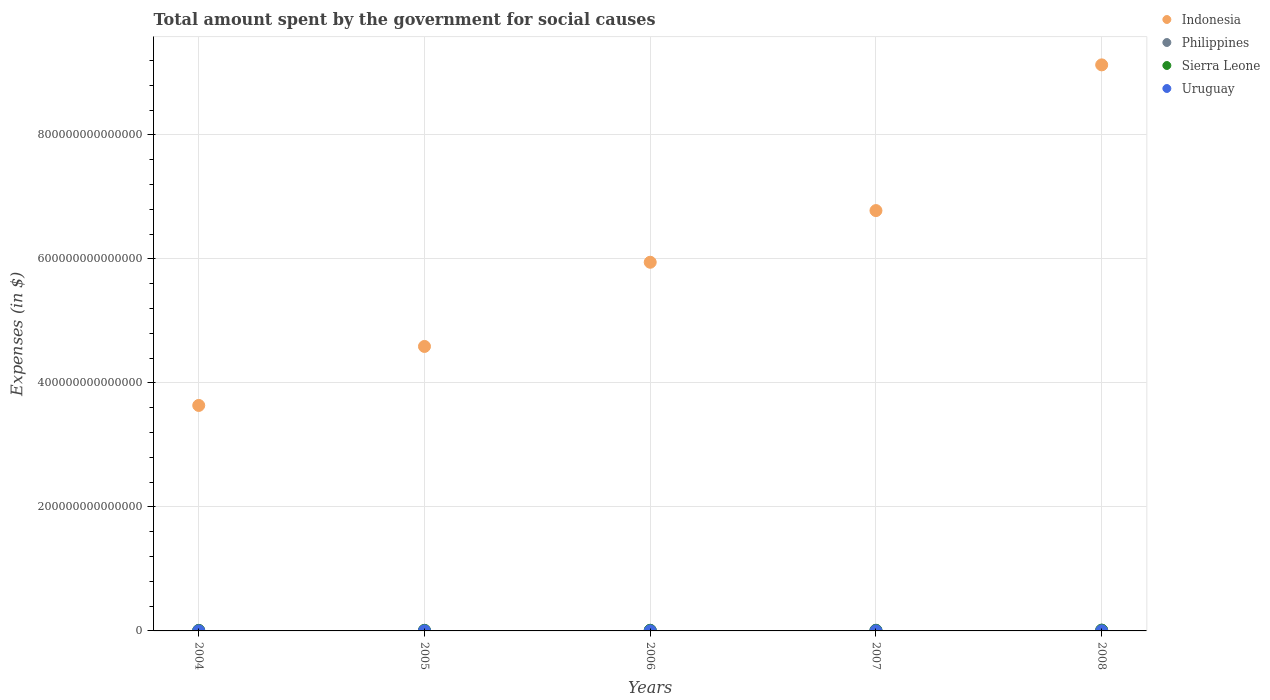How many different coloured dotlines are there?
Your answer should be compact. 4. Is the number of dotlines equal to the number of legend labels?
Offer a terse response. Yes. What is the amount spent for social causes by the government in Uruguay in 2008?
Keep it short and to the point. 1.63e+11. Across all years, what is the maximum amount spent for social causes by the government in Sierra Leone?
Your answer should be very brief. 1.18e+12. Across all years, what is the minimum amount spent for social causes by the government in Philippines?
Ensure brevity in your answer.  9.06e+11. In which year was the amount spent for social causes by the government in Philippines maximum?
Offer a terse response. 2008. In which year was the amount spent for social causes by the government in Indonesia minimum?
Offer a terse response. 2004. What is the total amount spent for social causes by the government in Philippines in the graph?
Provide a short and direct response. 5.35e+12. What is the difference between the amount spent for social causes by the government in Uruguay in 2007 and that in 2008?
Offer a very short reply. -1.73e+1. What is the difference between the amount spent for social causes by the government in Uruguay in 2004 and the amount spent for social causes by the government in Sierra Leone in 2005?
Give a very brief answer. -7.18e+11. What is the average amount spent for social causes by the government in Uruguay per year?
Offer a very short reply. 1.30e+11. In the year 2006, what is the difference between the amount spent for social causes by the government in Indonesia and amount spent for social causes by the government in Uruguay?
Make the answer very short. 5.94e+14. In how many years, is the amount spent for social causes by the government in Uruguay greater than 240000000000000 $?
Offer a terse response. 0. What is the ratio of the amount spent for social causes by the government in Philippines in 2006 to that in 2007?
Make the answer very short. 0.92. Is the amount spent for social causes by the government in Philippines in 2004 less than that in 2007?
Your response must be concise. Yes. What is the difference between the highest and the second highest amount spent for social causes by the government in Philippines?
Offer a very short reply. 1.21e+11. What is the difference between the highest and the lowest amount spent for social causes by the government in Indonesia?
Offer a terse response. 5.49e+14. In how many years, is the amount spent for social causes by the government in Sierra Leone greater than the average amount spent for social causes by the government in Sierra Leone taken over all years?
Your answer should be very brief. 2. Is the sum of the amount spent for social causes by the government in Uruguay in 2007 and 2008 greater than the maximum amount spent for social causes by the government in Indonesia across all years?
Your response must be concise. No. Does the amount spent for social causes by the government in Philippines monotonically increase over the years?
Provide a short and direct response. Yes. Is the amount spent for social causes by the government in Indonesia strictly less than the amount spent for social causes by the government in Uruguay over the years?
Provide a short and direct response. No. How many dotlines are there?
Keep it short and to the point. 4. How many years are there in the graph?
Your response must be concise. 5. What is the difference between two consecutive major ticks on the Y-axis?
Your answer should be compact. 2.00e+14. Does the graph contain any zero values?
Give a very brief answer. No. How are the legend labels stacked?
Provide a short and direct response. Vertical. What is the title of the graph?
Ensure brevity in your answer.  Total amount spent by the government for social causes. What is the label or title of the X-axis?
Ensure brevity in your answer.  Years. What is the label or title of the Y-axis?
Provide a succinct answer. Expenses (in $). What is the Expenses (in $) in Indonesia in 2004?
Make the answer very short. 3.64e+14. What is the Expenses (in $) of Philippines in 2004?
Your answer should be compact. 9.06e+11. What is the Expenses (in $) of Sierra Leone in 2004?
Make the answer very short. 6.88e+11. What is the Expenses (in $) of Uruguay in 2004?
Offer a terse response. 1.04e+11. What is the Expenses (in $) in Indonesia in 2005?
Your response must be concise. 4.59e+14. What is the Expenses (in $) in Philippines in 2005?
Keep it short and to the point. 9.77e+11. What is the Expenses (in $) of Sierra Leone in 2005?
Give a very brief answer. 8.23e+11. What is the Expenses (in $) of Uruguay in 2005?
Your response must be concise. 1.13e+11. What is the Expenses (in $) in Indonesia in 2006?
Offer a terse response. 5.94e+14. What is the Expenses (in $) in Philippines in 2006?
Keep it short and to the point. 1.05e+12. What is the Expenses (in $) in Sierra Leone in 2006?
Your answer should be compact. 9.17e+11. What is the Expenses (in $) of Uruguay in 2006?
Your response must be concise. 1.27e+11. What is the Expenses (in $) of Indonesia in 2007?
Offer a terse response. 6.78e+14. What is the Expenses (in $) of Philippines in 2007?
Offer a very short reply. 1.15e+12. What is the Expenses (in $) in Sierra Leone in 2007?
Keep it short and to the point. 8.25e+11. What is the Expenses (in $) in Uruguay in 2007?
Your answer should be compact. 1.46e+11. What is the Expenses (in $) in Indonesia in 2008?
Keep it short and to the point. 9.13e+14. What is the Expenses (in $) in Philippines in 2008?
Provide a succinct answer. 1.27e+12. What is the Expenses (in $) in Sierra Leone in 2008?
Ensure brevity in your answer.  1.18e+12. What is the Expenses (in $) of Uruguay in 2008?
Give a very brief answer. 1.63e+11. Across all years, what is the maximum Expenses (in $) of Indonesia?
Keep it short and to the point. 9.13e+14. Across all years, what is the maximum Expenses (in $) of Philippines?
Offer a very short reply. 1.27e+12. Across all years, what is the maximum Expenses (in $) in Sierra Leone?
Your response must be concise. 1.18e+12. Across all years, what is the maximum Expenses (in $) of Uruguay?
Provide a succinct answer. 1.63e+11. Across all years, what is the minimum Expenses (in $) in Indonesia?
Provide a short and direct response. 3.64e+14. Across all years, what is the minimum Expenses (in $) in Philippines?
Give a very brief answer. 9.06e+11. Across all years, what is the minimum Expenses (in $) of Sierra Leone?
Your response must be concise. 6.88e+11. Across all years, what is the minimum Expenses (in $) of Uruguay?
Offer a terse response. 1.04e+11. What is the total Expenses (in $) in Indonesia in the graph?
Your answer should be compact. 3.01e+15. What is the total Expenses (in $) of Philippines in the graph?
Ensure brevity in your answer.  5.35e+12. What is the total Expenses (in $) of Sierra Leone in the graph?
Keep it short and to the point. 4.44e+12. What is the total Expenses (in $) of Uruguay in the graph?
Your answer should be compact. 6.52e+11. What is the difference between the Expenses (in $) in Indonesia in 2004 and that in 2005?
Offer a very short reply. -9.51e+13. What is the difference between the Expenses (in $) in Philippines in 2004 and that in 2005?
Give a very brief answer. -7.12e+1. What is the difference between the Expenses (in $) in Sierra Leone in 2004 and that in 2005?
Ensure brevity in your answer.  -1.35e+11. What is the difference between the Expenses (in $) of Uruguay in 2004 and that in 2005?
Your answer should be compact. -8.41e+09. What is the difference between the Expenses (in $) in Indonesia in 2004 and that in 2006?
Your answer should be very brief. -2.31e+14. What is the difference between the Expenses (in $) in Philippines in 2004 and that in 2006?
Give a very brief answer. -1.48e+11. What is the difference between the Expenses (in $) in Sierra Leone in 2004 and that in 2006?
Your answer should be compact. -2.29e+11. What is the difference between the Expenses (in $) of Uruguay in 2004 and that in 2006?
Your answer should be very brief. -2.22e+1. What is the difference between the Expenses (in $) of Indonesia in 2004 and that in 2007?
Offer a terse response. -3.14e+14. What is the difference between the Expenses (in $) in Philippines in 2004 and that in 2007?
Make the answer very short. -2.39e+11. What is the difference between the Expenses (in $) in Sierra Leone in 2004 and that in 2007?
Your answer should be compact. -1.37e+11. What is the difference between the Expenses (in $) of Uruguay in 2004 and that in 2007?
Offer a terse response. -4.11e+1. What is the difference between the Expenses (in $) in Indonesia in 2004 and that in 2008?
Offer a very short reply. -5.49e+14. What is the difference between the Expenses (in $) of Philippines in 2004 and that in 2008?
Provide a short and direct response. -3.60e+11. What is the difference between the Expenses (in $) of Sierra Leone in 2004 and that in 2008?
Your answer should be very brief. -4.97e+11. What is the difference between the Expenses (in $) in Uruguay in 2004 and that in 2008?
Your answer should be very brief. -5.84e+1. What is the difference between the Expenses (in $) in Indonesia in 2005 and that in 2006?
Your answer should be very brief. -1.36e+14. What is the difference between the Expenses (in $) of Philippines in 2005 and that in 2006?
Provide a short and direct response. -7.71e+1. What is the difference between the Expenses (in $) in Sierra Leone in 2005 and that in 2006?
Provide a short and direct response. -9.44e+1. What is the difference between the Expenses (in $) of Uruguay in 2005 and that in 2006?
Your response must be concise. -1.37e+1. What is the difference between the Expenses (in $) of Indonesia in 2005 and that in 2007?
Give a very brief answer. -2.19e+14. What is the difference between the Expenses (in $) in Philippines in 2005 and that in 2007?
Make the answer very short. -1.68e+11. What is the difference between the Expenses (in $) of Sierra Leone in 2005 and that in 2007?
Offer a very short reply. -1.90e+09. What is the difference between the Expenses (in $) in Uruguay in 2005 and that in 2007?
Ensure brevity in your answer.  -3.27e+1. What is the difference between the Expenses (in $) of Indonesia in 2005 and that in 2008?
Your answer should be very brief. -4.54e+14. What is the difference between the Expenses (in $) of Philippines in 2005 and that in 2008?
Your answer should be very brief. -2.89e+11. What is the difference between the Expenses (in $) in Sierra Leone in 2005 and that in 2008?
Keep it short and to the point. -3.62e+11. What is the difference between the Expenses (in $) in Uruguay in 2005 and that in 2008?
Offer a very short reply. -5.00e+1. What is the difference between the Expenses (in $) in Indonesia in 2006 and that in 2007?
Give a very brief answer. -8.33e+13. What is the difference between the Expenses (in $) in Philippines in 2006 and that in 2007?
Keep it short and to the point. -9.11e+1. What is the difference between the Expenses (in $) of Sierra Leone in 2006 and that in 2007?
Your answer should be very brief. 9.25e+1. What is the difference between the Expenses (in $) in Uruguay in 2006 and that in 2007?
Your response must be concise. -1.89e+1. What is the difference between the Expenses (in $) in Indonesia in 2006 and that in 2008?
Offer a very short reply. -3.18e+14. What is the difference between the Expenses (in $) in Philippines in 2006 and that in 2008?
Offer a very short reply. -2.12e+11. What is the difference between the Expenses (in $) in Sierra Leone in 2006 and that in 2008?
Ensure brevity in your answer.  -2.67e+11. What is the difference between the Expenses (in $) of Uruguay in 2006 and that in 2008?
Provide a succinct answer. -3.63e+1. What is the difference between the Expenses (in $) of Indonesia in 2007 and that in 2008?
Your response must be concise. -2.35e+14. What is the difference between the Expenses (in $) in Philippines in 2007 and that in 2008?
Offer a very short reply. -1.21e+11. What is the difference between the Expenses (in $) of Sierra Leone in 2007 and that in 2008?
Ensure brevity in your answer.  -3.60e+11. What is the difference between the Expenses (in $) in Uruguay in 2007 and that in 2008?
Make the answer very short. -1.73e+1. What is the difference between the Expenses (in $) in Indonesia in 2004 and the Expenses (in $) in Philippines in 2005?
Provide a succinct answer. 3.63e+14. What is the difference between the Expenses (in $) of Indonesia in 2004 and the Expenses (in $) of Sierra Leone in 2005?
Provide a succinct answer. 3.63e+14. What is the difference between the Expenses (in $) of Indonesia in 2004 and the Expenses (in $) of Uruguay in 2005?
Make the answer very short. 3.63e+14. What is the difference between the Expenses (in $) in Philippines in 2004 and the Expenses (in $) in Sierra Leone in 2005?
Ensure brevity in your answer.  8.26e+1. What is the difference between the Expenses (in $) of Philippines in 2004 and the Expenses (in $) of Uruguay in 2005?
Make the answer very short. 7.93e+11. What is the difference between the Expenses (in $) in Sierra Leone in 2004 and the Expenses (in $) in Uruguay in 2005?
Keep it short and to the point. 5.75e+11. What is the difference between the Expenses (in $) of Indonesia in 2004 and the Expenses (in $) of Philippines in 2006?
Provide a short and direct response. 3.63e+14. What is the difference between the Expenses (in $) of Indonesia in 2004 and the Expenses (in $) of Sierra Leone in 2006?
Your answer should be compact. 3.63e+14. What is the difference between the Expenses (in $) in Indonesia in 2004 and the Expenses (in $) in Uruguay in 2006?
Your answer should be compact. 3.63e+14. What is the difference between the Expenses (in $) of Philippines in 2004 and the Expenses (in $) of Sierra Leone in 2006?
Provide a succinct answer. -1.17e+1. What is the difference between the Expenses (in $) in Philippines in 2004 and the Expenses (in $) in Uruguay in 2006?
Give a very brief answer. 7.79e+11. What is the difference between the Expenses (in $) of Sierra Leone in 2004 and the Expenses (in $) of Uruguay in 2006?
Your answer should be very brief. 5.61e+11. What is the difference between the Expenses (in $) in Indonesia in 2004 and the Expenses (in $) in Philippines in 2007?
Ensure brevity in your answer.  3.62e+14. What is the difference between the Expenses (in $) of Indonesia in 2004 and the Expenses (in $) of Sierra Leone in 2007?
Offer a terse response. 3.63e+14. What is the difference between the Expenses (in $) in Indonesia in 2004 and the Expenses (in $) in Uruguay in 2007?
Your answer should be compact. 3.63e+14. What is the difference between the Expenses (in $) of Philippines in 2004 and the Expenses (in $) of Sierra Leone in 2007?
Your answer should be very brief. 8.07e+1. What is the difference between the Expenses (in $) in Philippines in 2004 and the Expenses (in $) in Uruguay in 2007?
Your response must be concise. 7.60e+11. What is the difference between the Expenses (in $) of Sierra Leone in 2004 and the Expenses (in $) of Uruguay in 2007?
Provide a short and direct response. 5.43e+11. What is the difference between the Expenses (in $) of Indonesia in 2004 and the Expenses (in $) of Philippines in 2008?
Keep it short and to the point. 3.62e+14. What is the difference between the Expenses (in $) in Indonesia in 2004 and the Expenses (in $) in Sierra Leone in 2008?
Provide a succinct answer. 3.62e+14. What is the difference between the Expenses (in $) of Indonesia in 2004 and the Expenses (in $) of Uruguay in 2008?
Offer a very short reply. 3.63e+14. What is the difference between the Expenses (in $) in Philippines in 2004 and the Expenses (in $) in Sierra Leone in 2008?
Give a very brief answer. -2.79e+11. What is the difference between the Expenses (in $) in Philippines in 2004 and the Expenses (in $) in Uruguay in 2008?
Provide a succinct answer. 7.43e+11. What is the difference between the Expenses (in $) of Sierra Leone in 2004 and the Expenses (in $) of Uruguay in 2008?
Provide a short and direct response. 5.25e+11. What is the difference between the Expenses (in $) in Indonesia in 2005 and the Expenses (in $) in Philippines in 2006?
Your answer should be very brief. 4.58e+14. What is the difference between the Expenses (in $) in Indonesia in 2005 and the Expenses (in $) in Sierra Leone in 2006?
Keep it short and to the point. 4.58e+14. What is the difference between the Expenses (in $) of Indonesia in 2005 and the Expenses (in $) of Uruguay in 2006?
Your answer should be compact. 4.59e+14. What is the difference between the Expenses (in $) in Philippines in 2005 and the Expenses (in $) in Sierra Leone in 2006?
Give a very brief answer. 5.95e+1. What is the difference between the Expenses (in $) in Philippines in 2005 and the Expenses (in $) in Uruguay in 2006?
Offer a terse response. 8.50e+11. What is the difference between the Expenses (in $) of Sierra Leone in 2005 and the Expenses (in $) of Uruguay in 2006?
Keep it short and to the point. 6.96e+11. What is the difference between the Expenses (in $) in Indonesia in 2005 and the Expenses (in $) in Philippines in 2007?
Provide a short and direct response. 4.58e+14. What is the difference between the Expenses (in $) of Indonesia in 2005 and the Expenses (in $) of Sierra Leone in 2007?
Your answer should be very brief. 4.58e+14. What is the difference between the Expenses (in $) of Indonesia in 2005 and the Expenses (in $) of Uruguay in 2007?
Give a very brief answer. 4.59e+14. What is the difference between the Expenses (in $) of Philippines in 2005 and the Expenses (in $) of Sierra Leone in 2007?
Your answer should be very brief. 1.52e+11. What is the difference between the Expenses (in $) in Philippines in 2005 and the Expenses (in $) in Uruguay in 2007?
Your response must be concise. 8.31e+11. What is the difference between the Expenses (in $) in Sierra Leone in 2005 and the Expenses (in $) in Uruguay in 2007?
Offer a very short reply. 6.77e+11. What is the difference between the Expenses (in $) in Indonesia in 2005 and the Expenses (in $) in Philippines in 2008?
Your answer should be very brief. 4.57e+14. What is the difference between the Expenses (in $) of Indonesia in 2005 and the Expenses (in $) of Sierra Leone in 2008?
Offer a terse response. 4.58e+14. What is the difference between the Expenses (in $) in Indonesia in 2005 and the Expenses (in $) in Uruguay in 2008?
Offer a very short reply. 4.59e+14. What is the difference between the Expenses (in $) in Philippines in 2005 and the Expenses (in $) in Sierra Leone in 2008?
Your response must be concise. -2.08e+11. What is the difference between the Expenses (in $) in Philippines in 2005 and the Expenses (in $) in Uruguay in 2008?
Your answer should be very brief. 8.14e+11. What is the difference between the Expenses (in $) in Sierra Leone in 2005 and the Expenses (in $) in Uruguay in 2008?
Give a very brief answer. 6.60e+11. What is the difference between the Expenses (in $) of Indonesia in 2006 and the Expenses (in $) of Philippines in 2007?
Ensure brevity in your answer.  5.93e+14. What is the difference between the Expenses (in $) in Indonesia in 2006 and the Expenses (in $) in Sierra Leone in 2007?
Give a very brief answer. 5.94e+14. What is the difference between the Expenses (in $) of Indonesia in 2006 and the Expenses (in $) of Uruguay in 2007?
Your response must be concise. 5.94e+14. What is the difference between the Expenses (in $) in Philippines in 2006 and the Expenses (in $) in Sierra Leone in 2007?
Ensure brevity in your answer.  2.29e+11. What is the difference between the Expenses (in $) in Philippines in 2006 and the Expenses (in $) in Uruguay in 2007?
Keep it short and to the point. 9.08e+11. What is the difference between the Expenses (in $) in Sierra Leone in 2006 and the Expenses (in $) in Uruguay in 2007?
Offer a terse response. 7.72e+11. What is the difference between the Expenses (in $) of Indonesia in 2006 and the Expenses (in $) of Philippines in 2008?
Keep it short and to the point. 5.93e+14. What is the difference between the Expenses (in $) in Indonesia in 2006 and the Expenses (in $) in Sierra Leone in 2008?
Provide a succinct answer. 5.93e+14. What is the difference between the Expenses (in $) in Indonesia in 2006 and the Expenses (in $) in Uruguay in 2008?
Provide a succinct answer. 5.94e+14. What is the difference between the Expenses (in $) of Philippines in 2006 and the Expenses (in $) of Sierra Leone in 2008?
Offer a terse response. -1.31e+11. What is the difference between the Expenses (in $) of Philippines in 2006 and the Expenses (in $) of Uruguay in 2008?
Your answer should be very brief. 8.91e+11. What is the difference between the Expenses (in $) of Sierra Leone in 2006 and the Expenses (in $) of Uruguay in 2008?
Offer a terse response. 7.54e+11. What is the difference between the Expenses (in $) in Indonesia in 2007 and the Expenses (in $) in Philippines in 2008?
Offer a very short reply. 6.77e+14. What is the difference between the Expenses (in $) of Indonesia in 2007 and the Expenses (in $) of Sierra Leone in 2008?
Offer a terse response. 6.77e+14. What is the difference between the Expenses (in $) in Indonesia in 2007 and the Expenses (in $) in Uruguay in 2008?
Your answer should be very brief. 6.78e+14. What is the difference between the Expenses (in $) in Philippines in 2007 and the Expenses (in $) in Sierra Leone in 2008?
Provide a succinct answer. -3.97e+1. What is the difference between the Expenses (in $) of Philippines in 2007 and the Expenses (in $) of Uruguay in 2008?
Offer a very short reply. 9.82e+11. What is the difference between the Expenses (in $) in Sierra Leone in 2007 and the Expenses (in $) in Uruguay in 2008?
Your response must be concise. 6.62e+11. What is the average Expenses (in $) of Indonesia per year?
Your answer should be compact. 6.01e+14. What is the average Expenses (in $) in Philippines per year?
Provide a succinct answer. 1.07e+12. What is the average Expenses (in $) of Sierra Leone per year?
Ensure brevity in your answer.  8.88e+11. What is the average Expenses (in $) of Uruguay per year?
Your response must be concise. 1.30e+11. In the year 2004, what is the difference between the Expenses (in $) of Indonesia and Expenses (in $) of Philippines?
Ensure brevity in your answer.  3.63e+14. In the year 2004, what is the difference between the Expenses (in $) in Indonesia and Expenses (in $) in Sierra Leone?
Provide a succinct answer. 3.63e+14. In the year 2004, what is the difference between the Expenses (in $) of Indonesia and Expenses (in $) of Uruguay?
Your answer should be very brief. 3.64e+14. In the year 2004, what is the difference between the Expenses (in $) of Philippines and Expenses (in $) of Sierra Leone?
Make the answer very short. 2.17e+11. In the year 2004, what is the difference between the Expenses (in $) of Philippines and Expenses (in $) of Uruguay?
Offer a terse response. 8.01e+11. In the year 2004, what is the difference between the Expenses (in $) of Sierra Leone and Expenses (in $) of Uruguay?
Make the answer very short. 5.84e+11. In the year 2005, what is the difference between the Expenses (in $) of Indonesia and Expenses (in $) of Philippines?
Provide a succinct answer. 4.58e+14. In the year 2005, what is the difference between the Expenses (in $) of Indonesia and Expenses (in $) of Sierra Leone?
Offer a very short reply. 4.58e+14. In the year 2005, what is the difference between the Expenses (in $) of Indonesia and Expenses (in $) of Uruguay?
Make the answer very short. 4.59e+14. In the year 2005, what is the difference between the Expenses (in $) of Philippines and Expenses (in $) of Sierra Leone?
Offer a very short reply. 1.54e+11. In the year 2005, what is the difference between the Expenses (in $) of Philippines and Expenses (in $) of Uruguay?
Give a very brief answer. 8.64e+11. In the year 2005, what is the difference between the Expenses (in $) in Sierra Leone and Expenses (in $) in Uruguay?
Provide a succinct answer. 7.10e+11. In the year 2006, what is the difference between the Expenses (in $) in Indonesia and Expenses (in $) in Philippines?
Offer a very short reply. 5.93e+14. In the year 2006, what is the difference between the Expenses (in $) in Indonesia and Expenses (in $) in Sierra Leone?
Keep it short and to the point. 5.94e+14. In the year 2006, what is the difference between the Expenses (in $) in Indonesia and Expenses (in $) in Uruguay?
Your response must be concise. 5.94e+14. In the year 2006, what is the difference between the Expenses (in $) of Philippines and Expenses (in $) of Sierra Leone?
Your response must be concise. 1.37e+11. In the year 2006, what is the difference between the Expenses (in $) in Philippines and Expenses (in $) in Uruguay?
Offer a terse response. 9.27e+11. In the year 2006, what is the difference between the Expenses (in $) of Sierra Leone and Expenses (in $) of Uruguay?
Keep it short and to the point. 7.91e+11. In the year 2007, what is the difference between the Expenses (in $) in Indonesia and Expenses (in $) in Philippines?
Keep it short and to the point. 6.77e+14. In the year 2007, what is the difference between the Expenses (in $) of Indonesia and Expenses (in $) of Sierra Leone?
Provide a succinct answer. 6.77e+14. In the year 2007, what is the difference between the Expenses (in $) in Indonesia and Expenses (in $) in Uruguay?
Keep it short and to the point. 6.78e+14. In the year 2007, what is the difference between the Expenses (in $) in Philippines and Expenses (in $) in Sierra Leone?
Provide a succinct answer. 3.20e+11. In the year 2007, what is the difference between the Expenses (in $) in Philippines and Expenses (in $) in Uruguay?
Offer a terse response. 9.99e+11. In the year 2007, what is the difference between the Expenses (in $) of Sierra Leone and Expenses (in $) of Uruguay?
Provide a short and direct response. 6.79e+11. In the year 2008, what is the difference between the Expenses (in $) of Indonesia and Expenses (in $) of Philippines?
Your answer should be compact. 9.12e+14. In the year 2008, what is the difference between the Expenses (in $) of Indonesia and Expenses (in $) of Sierra Leone?
Offer a terse response. 9.12e+14. In the year 2008, what is the difference between the Expenses (in $) in Indonesia and Expenses (in $) in Uruguay?
Keep it short and to the point. 9.13e+14. In the year 2008, what is the difference between the Expenses (in $) in Philippines and Expenses (in $) in Sierra Leone?
Your response must be concise. 8.08e+1. In the year 2008, what is the difference between the Expenses (in $) of Philippines and Expenses (in $) of Uruguay?
Offer a terse response. 1.10e+12. In the year 2008, what is the difference between the Expenses (in $) in Sierra Leone and Expenses (in $) in Uruguay?
Ensure brevity in your answer.  1.02e+12. What is the ratio of the Expenses (in $) of Indonesia in 2004 to that in 2005?
Your answer should be very brief. 0.79. What is the ratio of the Expenses (in $) in Philippines in 2004 to that in 2005?
Your response must be concise. 0.93. What is the ratio of the Expenses (in $) of Sierra Leone in 2004 to that in 2005?
Make the answer very short. 0.84. What is the ratio of the Expenses (in $) in Uruguay in 2004 to that in 2005?
Offer a very short reply. 0.93. What is the ratio of the Expenses (in $) of Indonesia in 2004 to that in 2006?
Give a very brief answer. 0.61. What is the ratio of the Expenses (in $) in Philippines in 2004 to that in 2006?
Offer a terse response. 0.86. What is the ratio of the Expenses (in $) in Sierra Leone in 2004 to that in 2006?
Offer a terse response. 0.75. What is the ratio of the Expenses (in $) in Uruguay in 2004 to that in 2006?
Make the answer very short. 0.82. What is the ratio of the Expenses (in $) in Indonesia in 2004 to that in 2007?
Make the answer very short. 0.54. What is the ratio of the Expenses (in $) of Philippines in 2004 to that in 2007?
Ensure brevity in your answer.  0.79. What is the ratio of the Expenses (in $) in Sierra Leone in 2004 to that in 2007?
Give a very brief answer. 0.83. What is the ratio of the Expenses (in $) in Uruguay in 2004 to that in 2007?
Your response must be concise. 0.72. What is the ratio of the Expenses (in $) of Indonesia in 2004 to that in 2008?
Ensure brevity in your answer.  0.4. What is the ratio of the Expenses (in $) in Philippines in 2004 to that in 2008?
Your response must be concise. 0.72. What is the ratio of the Expenses (in $) of Sierra Leone in 2004 to that in 2008?
Offer a terse response. 0.58. What is the ratio of the Expenses (in $) in Uruguay in 2004 to that in 2008?
Provide a succinct answer. 0.64. What is the ratio of the Expenses (in $) in Indonesia in 2005 to that in 2006?
Provide a succinct answer. 0.77. What is the ratio of the Expenses (in $) of Philippines in 2005 to that in 2006?
Keep it short and to the point. 0.93. What is the ratio of the Expenses (in $) in Sierra Leone in 2005 to that in 2006?
Provide a succinct answer. 0.9. What is the ratio of the Expenses (in $) of Uruguay in 2005 to that in 2006?
Make the answer very short. 0.89. What is the ratio of the Expenses (in $) in Indonesia in 2005 to that in 2007?
Give a very brief answer. 0.68. What is the ratio of the Expenses (in $) of Philippines in 2005 to that in 2007?
Provide a short and direct response. 0.85. What is the ratio of the Expenses (in $) of Uruguay in 2005 to that in 2007?
Provide a succinct answer. 0.78. What is the ratio of the Expenses (in $) in Indonesia in 2005 to that in 2008?
Your answer should be compact. 0.5. What is the ratio of the Expenses (in $) of Philippines in 2005 to that in 2008?
Your response must be concise. 0.77. What is the ratio of the Expenses (in $) of Sierra Leone in 2005 to that in 2008?
Keep it short and to the point. 0.69. What is the ratio of the Expenses (in $) in Uruguay in 2005 to that in 2008?
Give a very brief answer. 0.69. What is the ratio of the Expenses (in $) in Indonesia in 2006 to that in 2007?
Make the answer very short. 0.88. What is the ratio of the Expenses (in $) in Philippines in 2006 to that in 2007?
Your answer should be very brief. 0.92. What is the ratio of the Expenses (in $) in Sierra Leone in 2006 to that in 2007?
Offer a very short reply. 1.11. What is the ratio of the Expenses (in $) in Uruguay in 2006 to that in 2007?
Your answer should be very brief. 0.87. What is the ratio of the Expenses (in $) in Indonesia in 2006 to that in 2008?
Offer a very short reply. 0.65. What is the ratio of the Expenses (in $) of Philippines in 2006 to that in 2008?
Provide a succinct answer. 0.83. What is the ratio of the Expenses (in $) of Sierra Leone in 2006 to that in 2008?
Ensure brevity in your answer.  0.77. What is the ratio of the Expenses (in $) of Uruguay in 2006 to that in 2008?
Your response must be concise. 0.78. What is the ratio of the Expenses (in $) of Indonesia in 2007 to that in 2008?
Your answer should be compact. 0.74. What is the ratio of the Expenses (in $) in Philippines in 2007 to that in 2008?
Keep it short and to the point. 0.9. What is the ratio of the Expenses (in $) in Sierra Leone in 2007 to that in 2008?
Offer a terse response. 0.7. What is the ratio of the Expenses (in $) in Uruguay in 2007 to that in 2008?
Offer a very short reply. 0.89. What is the difference between the highest and the second highest Expenses (in $) of Indonesia?
Offer a terse response. 2.35e+14. What is the difference between the highest and the second highest Expenses (in $) of Philippines?
Make the answer very short. 1.21e+11. What is the difference between the highest and the second highest Expenses (in $) in Sierra Leone?
Offer a terse response. 2.67e+11. What is the difference between the highest and the second highest Expenses (in $) of Uruguay?
Keep it short and to the point. 1.73e+1. What is the difference between the highest and the lowest Expenses (in $) in Indonesia?
Your answer should be compact. 5.49e+14. What is the difference between the highest and the lowest Expenses (in $) in Philippines?
Your answer should be very brief. 3.60e+11. What is the difference between the highest and the lowest Expenses (in $) in Sierra Leone?
Provide a succinct answer. 4.97e+11. What is the difference between the highest and the lowest Expenses (in $) in Uruguay?
Your answer should be very brief. 5.84e+1. 